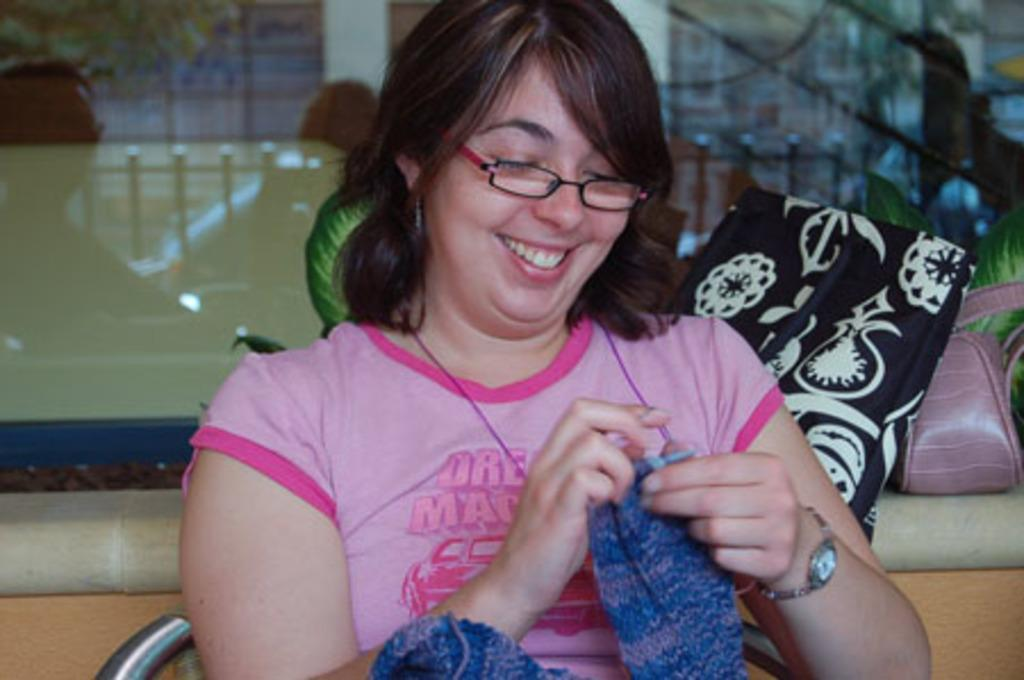Who is present in the image? There is a woman in the image. What is the woman doing in the image? The woman is sitting on a chair and smiling. What is the woman holding in the image? The woman is holding a cloth. What can be seen in the background of the image? There are bags on a platform, leaves, and a glass object visible in the background. What reason do the men in the image have for being there? There are no men present in the image, so there is no reason for them to be there. 